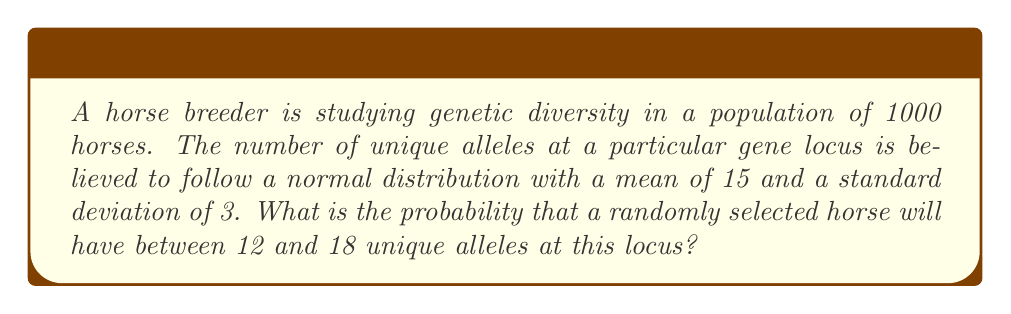Can you solve this math problem? To solve this problem, we need to use the properties of the normal distribution and standardize our values.

1) The given information:
   - Normal distribution with mean $\mu = 15$ and standard deviation $\sigma = 3$
   - We want to find P(12 < X < 18)

2) Standardize the values using the z-score formula:
   $z = \frac{x - \mu}{\sigma}$

   For x = 12: $z_1 = \frac{12 - 15}{3} = -1$
   For x = 18: $z_2 = \frac{18 - 15}{3} = 1$

3) Now we need to find P(-1 < Z < 1)

4) Using the standard normal distribution table or a calculator:
   P(Z < 1) = 0.8413
   P(Z < -1) = 0.1587

5) The probability we're looking for is:
   P(-1 < Z < 1) = P(Z < 1) - P(Z < -1)
                 = 0.8413 - 0.1587
                 = 0.6826

Therefore, the probability that a randomly selected horse will have between 12 and 18 unique alleles at this locus is approximately 0.6826 or 68.26%.
Answer: 0.6826 or 68.26% 